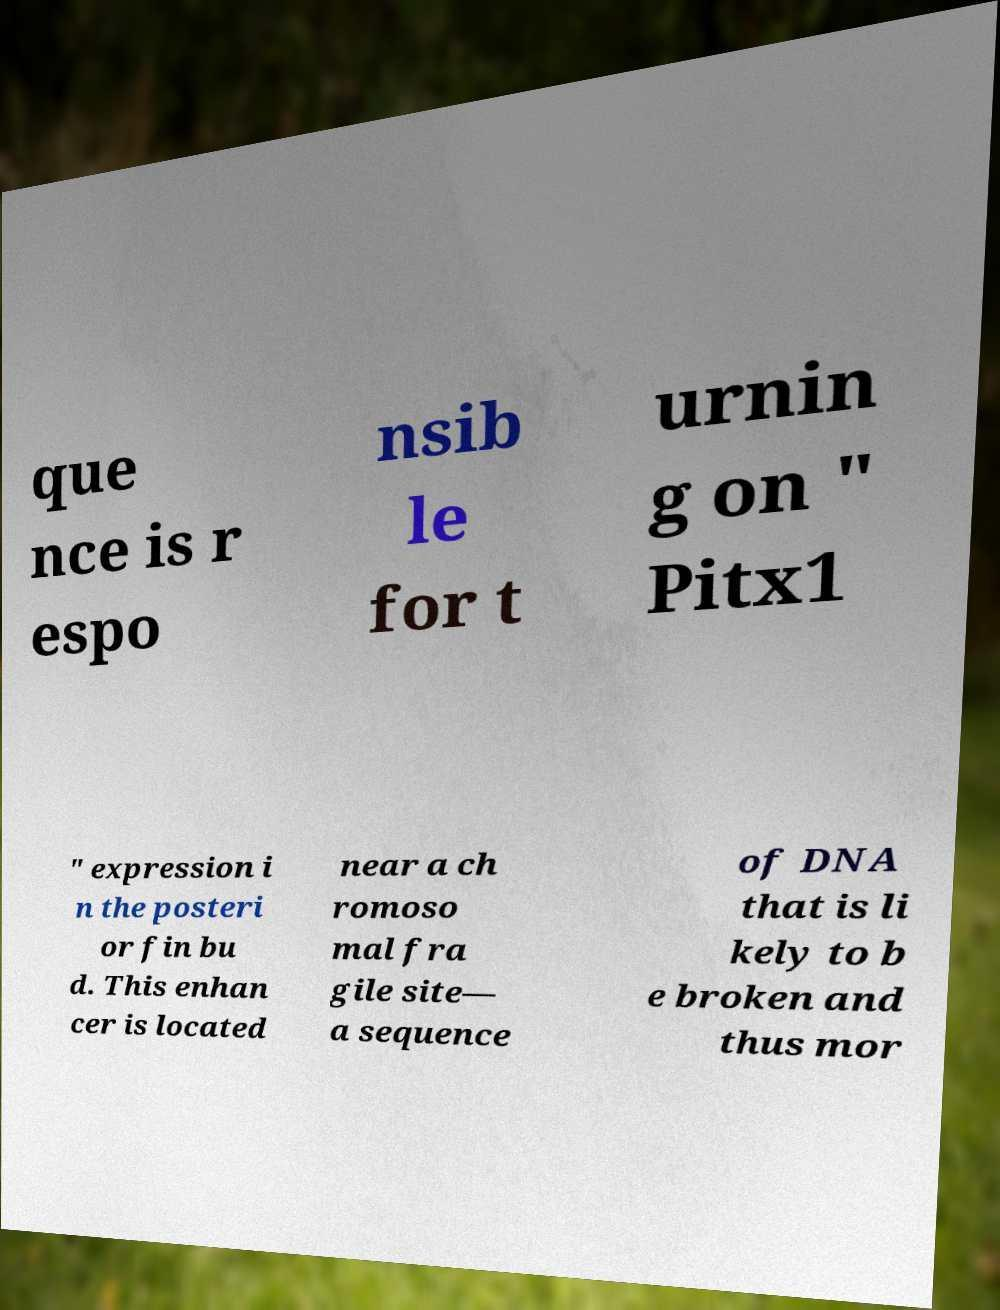What messages or text are displayed in this image? I need them in a readable, typed format. que nce is r espo nsib le for t urnin g on " Pitx1 " expression i n the posteri or fin bu d. This enhan cer is located near a ch romoso mal fra gile site— a sequence of DNA that is li kely to b e broken and thus mor 